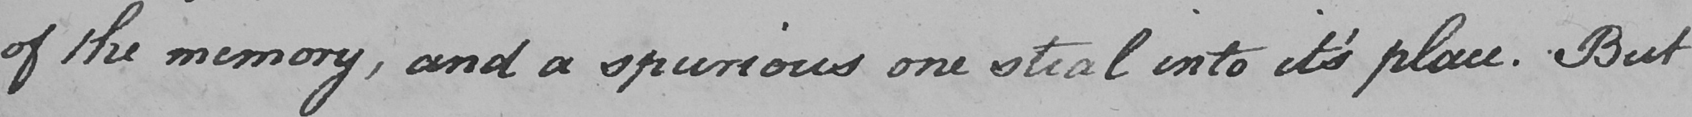Please provide the text content of this handwritten line. of the memory , and a spurious one steal into it ' s place . But  _ 